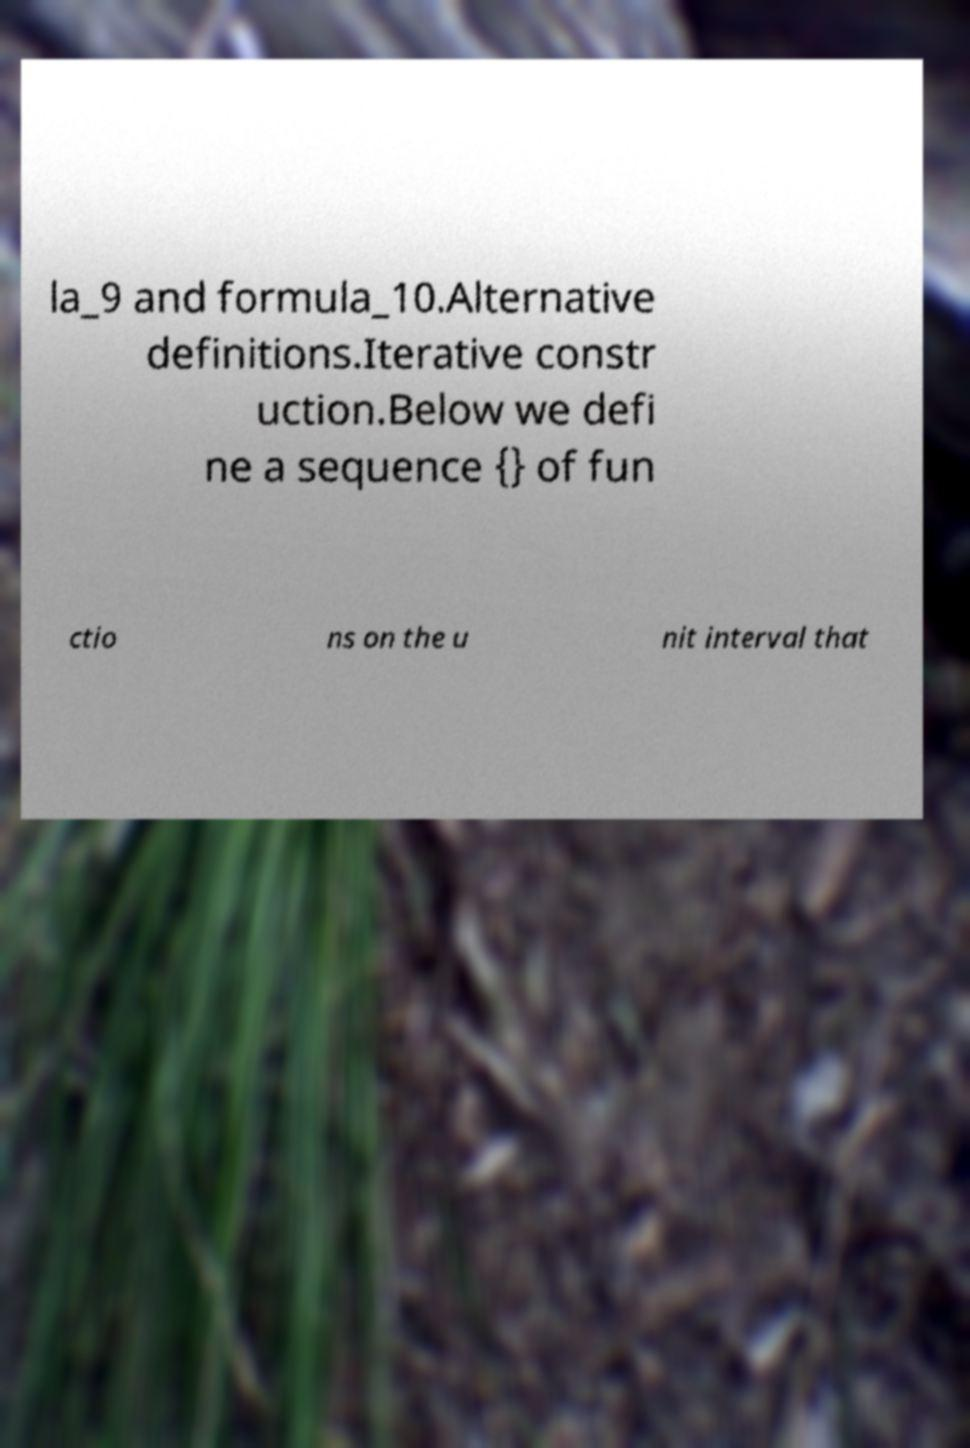Can you accurately transcribe the text from the provided image for me? la_9 and formula_10.Alternative definitions.Iterative constr uction.Below we defi ne a sequence {} of fun ctio ns on the u nit interval that 